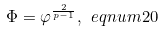Convert formula to latex. <formula><loc_0><loc_0><loc_500><loc_500>\Phi = \varphi ^ { \frac { 2 } { p - 1 } } , \ e q n u m { 2 0 }</formula> 